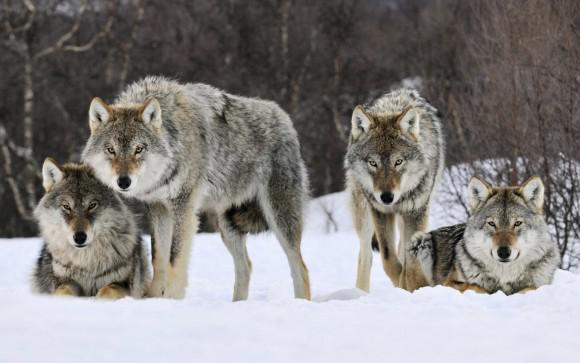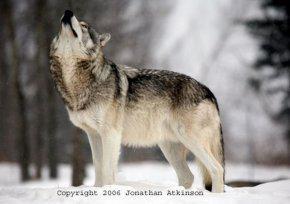The first image is the image on the left, the second image is the image on the right. Evaluate the accuracy of this statement regarding the images: "The left image includes a dog moving forward over snow toward the camera, and it includes a dog with an open mouth.". Is it true? Answer yes or no. No. The first image is the image on the left, the second image is the image on the right. Analyze the images presented: Is the assertion "There are fewer than four wolves." valid? Answer yes or no. No. 